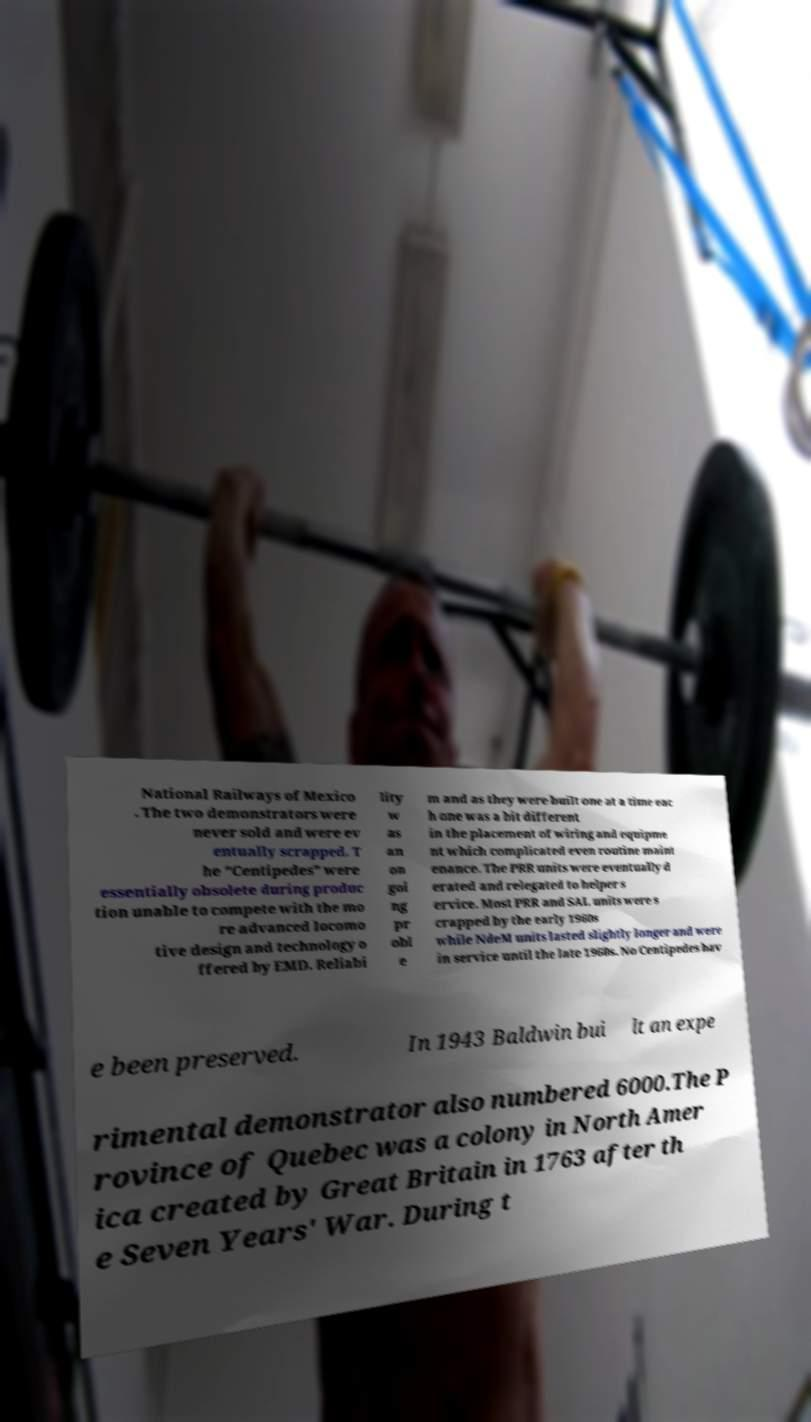Could you assist in decoding the text presented in this image and type it out clearly? National Railways of Mexico . The two demonstrators were never sold and were ev entually scrapped. T he "Centipedes" were essentially obsolete during produc tion unable to compete with the mo re advanced locomo tive design and technology o ffered by EMD. Reliabi lity w as an on goi ng pr obl e m and as they were built one at a time eac h one was a bit different in the placement of wiring and equipme nt which complicated even routine maint enance. The PRR units were eventually d erated and relegated to helper s ervice. Most PRR and SAL units were s crapped by the early 1960s while NdeM units lasted slightly longer and were in service until the late 1960s. No Centipedes hav e been preserved. In 1943 Baldwin bui lt an expe rimental demonstrator also numbered 6000.The P rovince of Quebec was a colony in North Amer ica created by Great Britain in 1763 after th e Seven Years' War. During t 